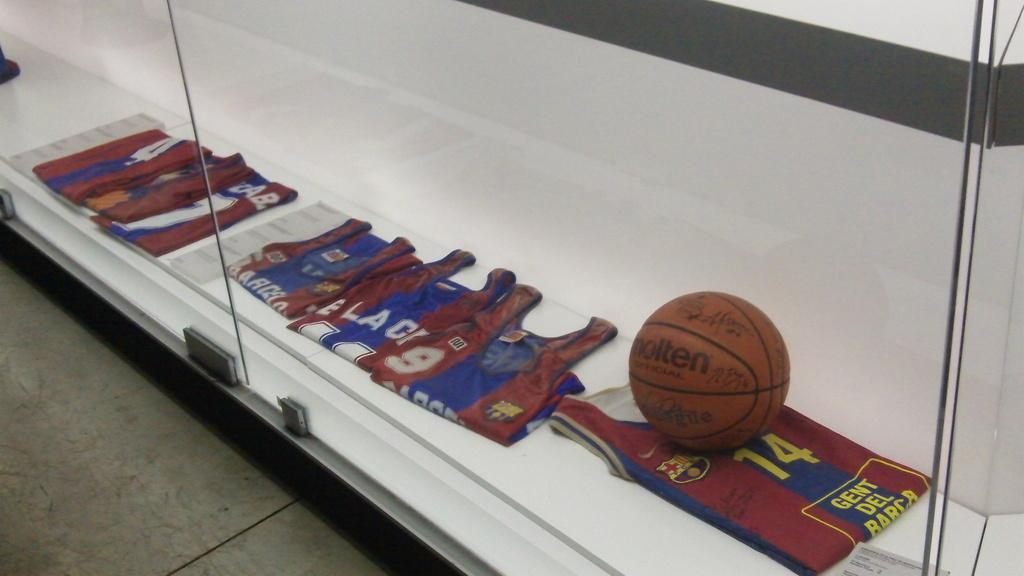<image>
Create a compact narrative representing the image presented. A display case contains a basketball and various jerseys, such as number 9 and number 24. 